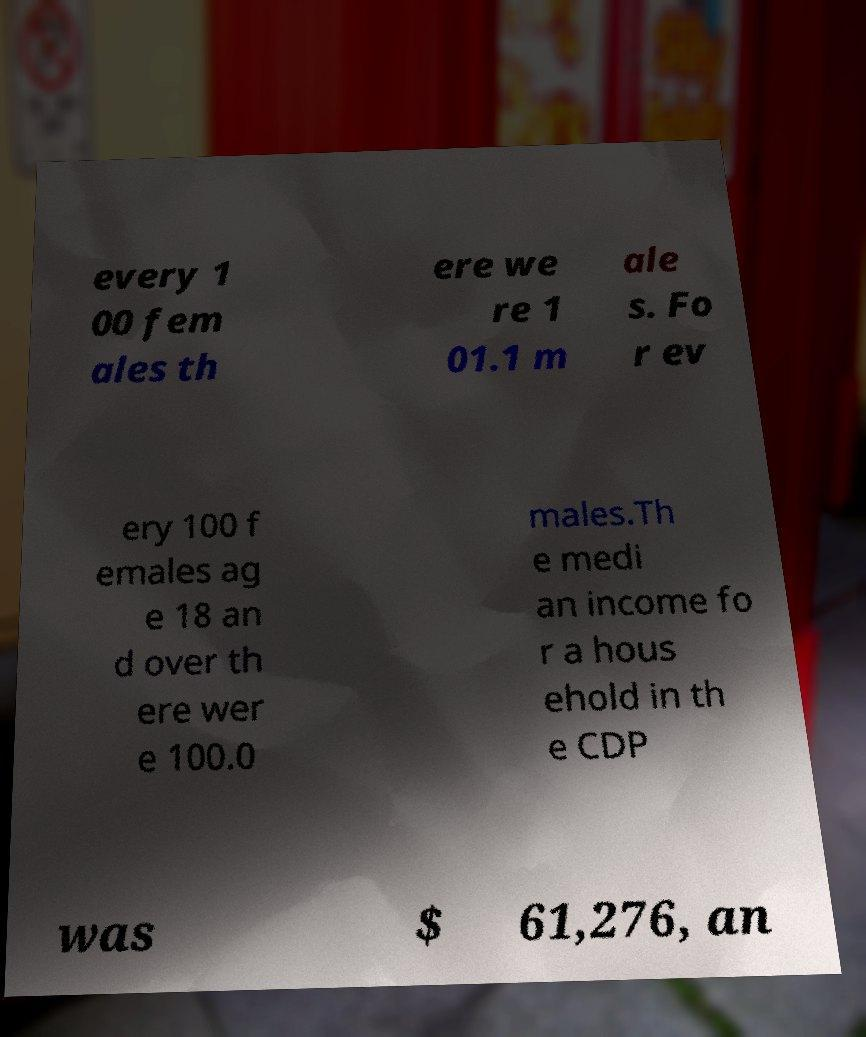Could you assist in decoding the text presented in this image and type it out clearly? every 1 00 fem ales th ere we re 1 01.1 m ale s. Fo r ev ery 100 f emales ag e 18 an d over th ere wer e 100.0 males.Th e medi an income fo r a hous ehold in th e CDP was $ 61,276, an 